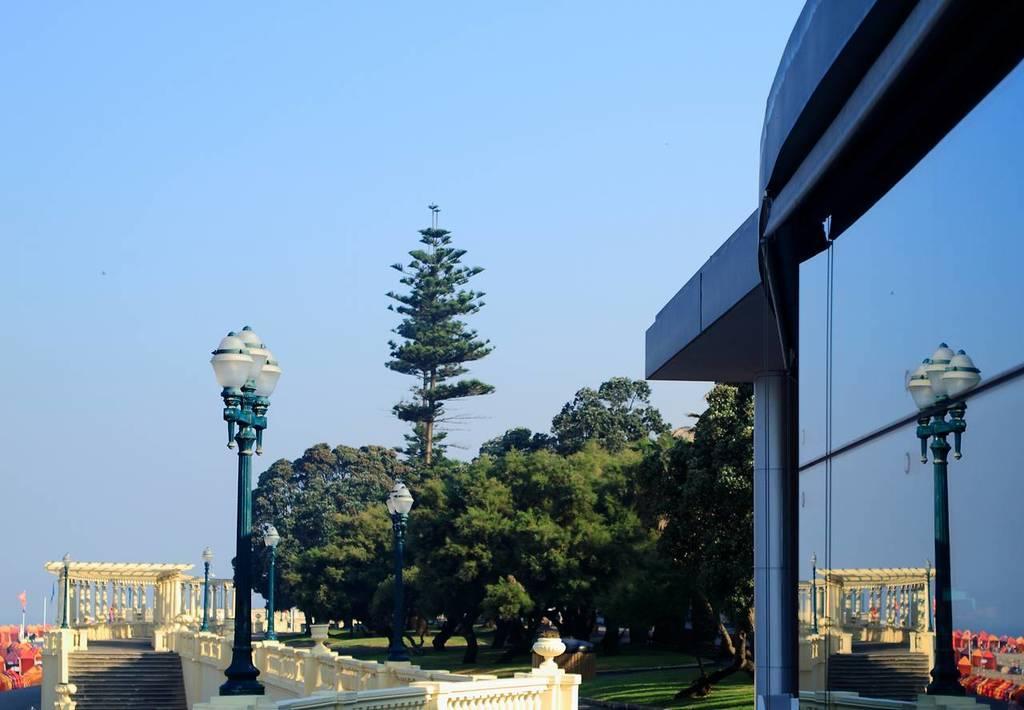Can you describe this image briefly? In this image we can see a building. On the left side we can see a monument with pillars and stairs and street poles on it. We can also see some group of trees, grass and the sky. 